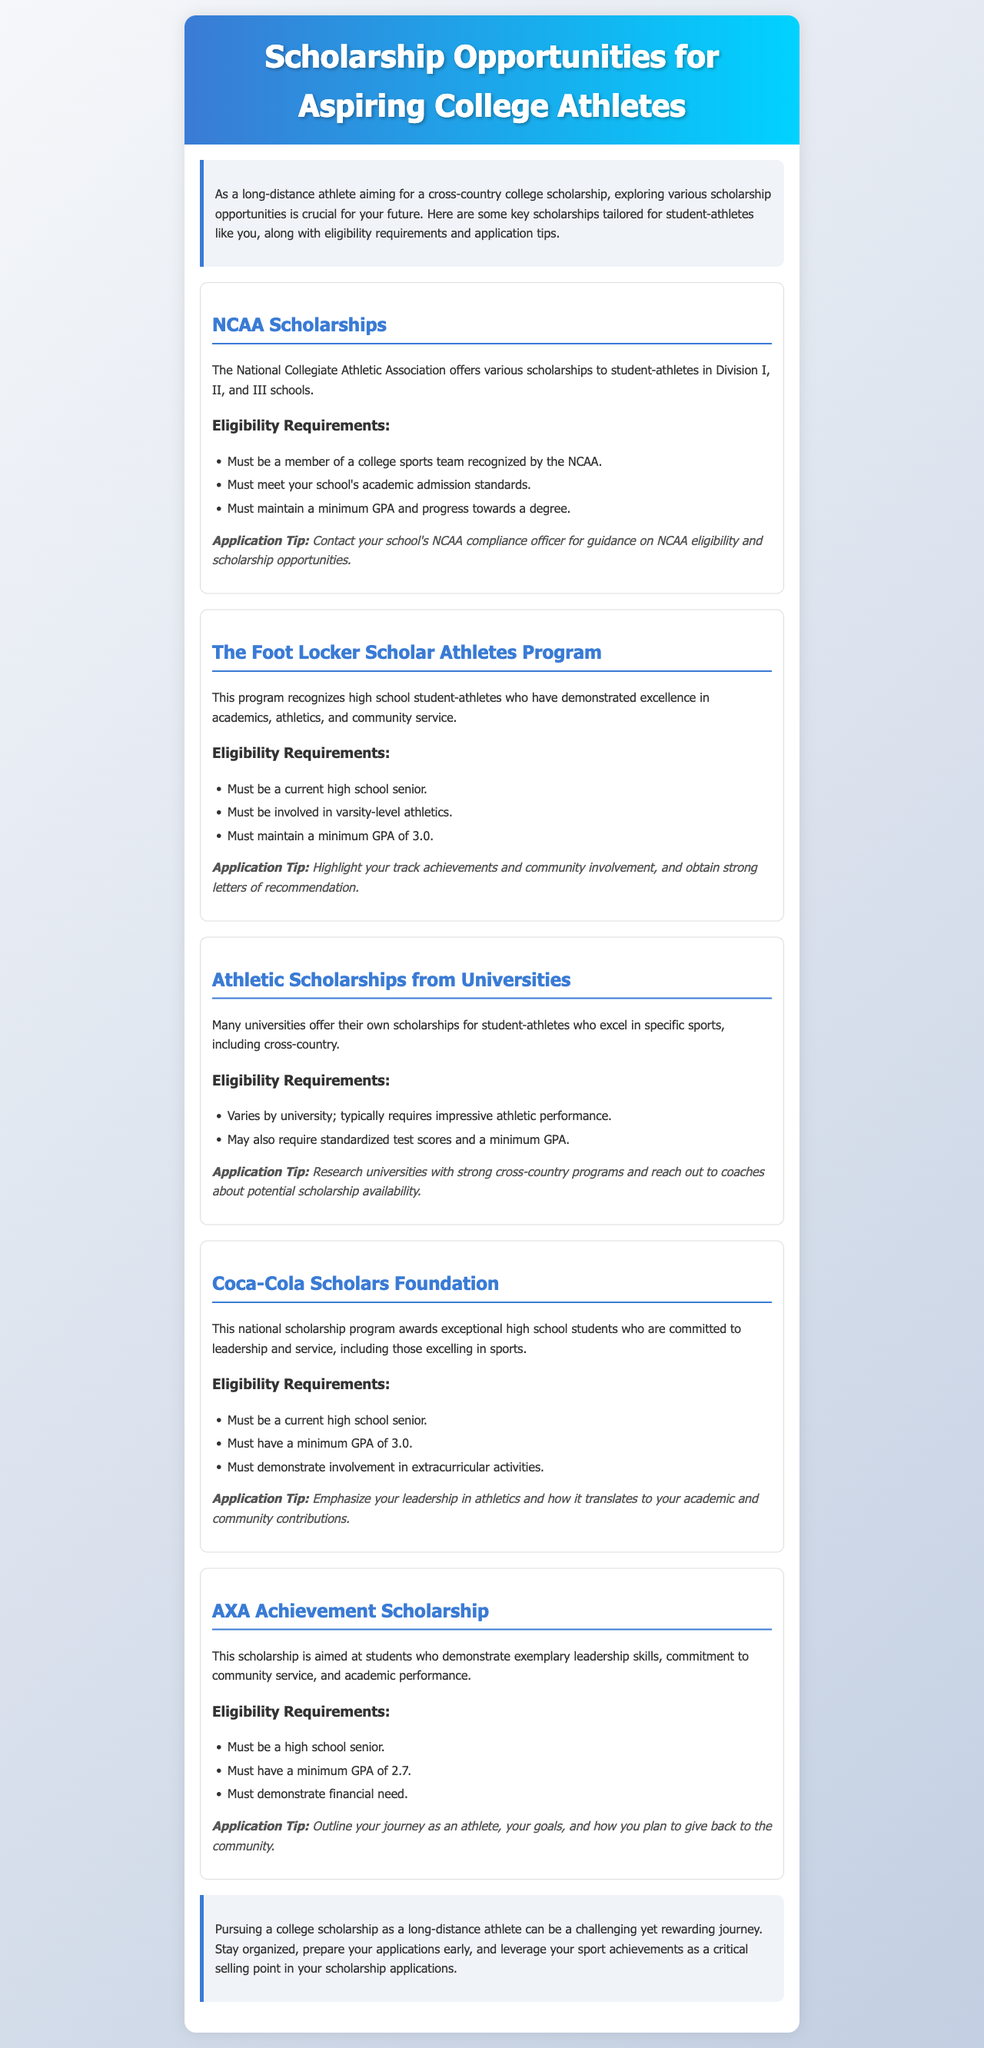What is the title of the newsletter? The title is found prominently at the top of the document in the header section.
Answer: Scholarship Opportunities for Aspiring College Athletes How many scholarship programs are listed? There are multiple sections in the document dedicated to different scholarships, totaling five distinct programs.
Answer: 5 What is the minimum GPA required for the Foot Locker Scholar Athletes Program? The document specifies a minimum GPA requirement within the eligibility section of that scholarship.
Answer: 3.0 What type of scholarship does the Coca-Cola Scholars Foundation award? The type of scholarship is highlighted in the opening paragraph of that section focused on the Coca-Cola program.
Answer: National scholarship What is a key application tip for NCAA Scholarships? The application tips section offers specific advice relevant to each scholarship; for NCAA, guidance is recommended from a compliance officer.
Answer: Contact your school's NCAA compliance officer What is the eligibility requirement for the AXA Achievement Scholarship regarding GPA? The specific eligibility requirement is mentioned in the overview of that scholarship program detailing academic standards.
Answer: 2.7 Which organization offers NCAA Scholarships? The organization responsible for this scholarship program is stated at the beginning of the corresponding scholarship section.
Answer: National Collegiate Athletic Association What is a common recommendation for applying to university scholarships? The application tips often include advice on interaction with university coaches regarding scholarship opportunities.
Answer: Reach out to coaches 